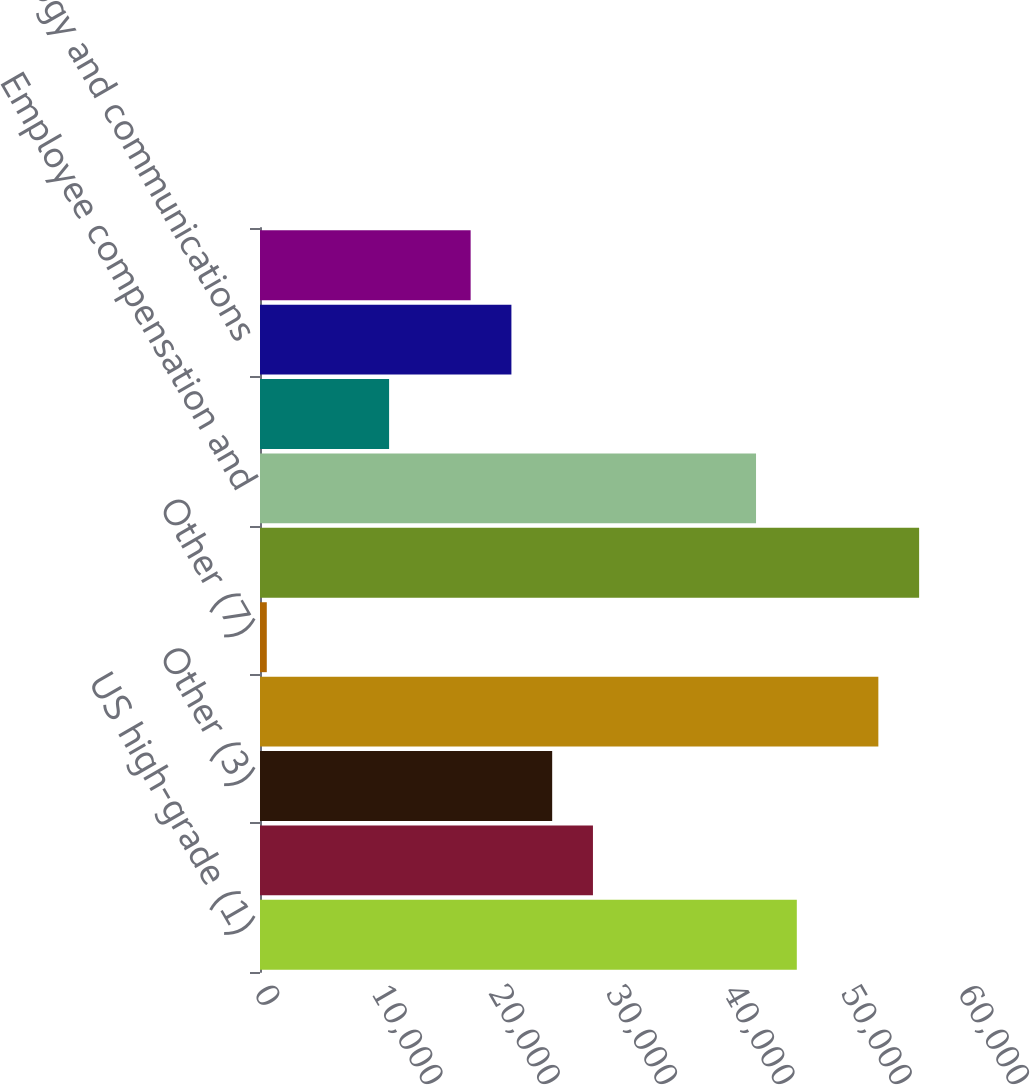<chart> <loc_0><loc_0><loc_500><loc_500><bar_chart><fcel>US high-grade (1)<fcel>Eurobond (2)<fcel>Other (3)<fcel>Total commissions<fcel>Other (7)<fcel>Total revenues<fcel>Employee compensation and<fcel>Depreciation and amortization<fcel>Technology and communications<fcel>Professional and consulting<nl><fcel>45750.4<fcel>28376.4<fcel>24901.6<fcel>52700<fcel>578<fcel>56174.8<fcel>42275.6<fcel>11002.4<fcel>21426.8<fcel>17952<nl></chart> 